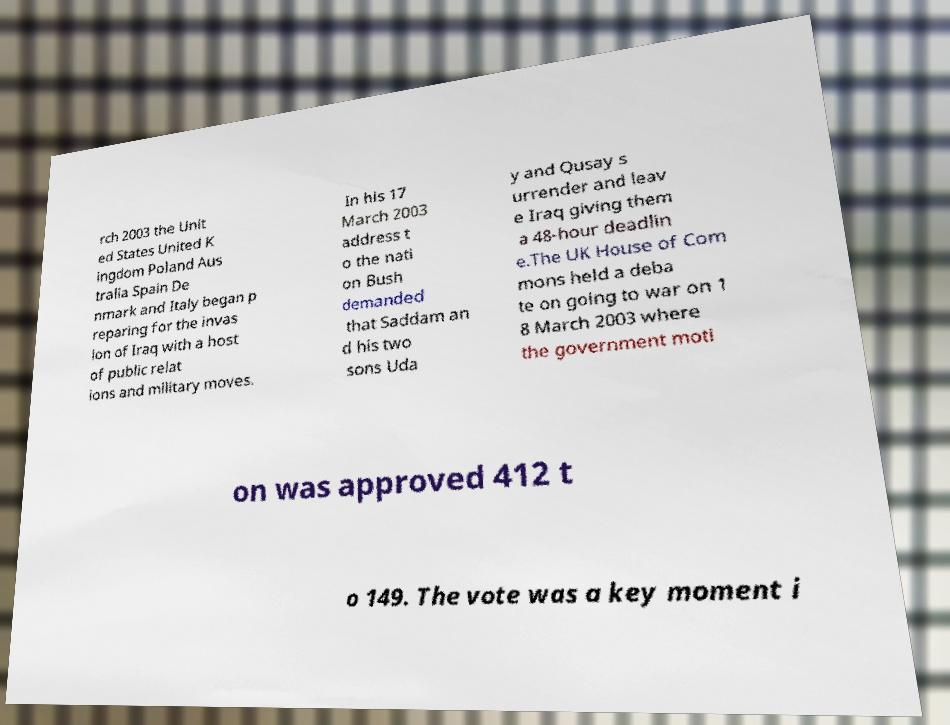Can you read and provide the text displayed in the image?This photo seems to have some interesting text. Can you extract and type it out for me? rch 2003 the Unit ed States United K ingdom Poland Aus tralia Spain De nmark and Italy began p reparing for the invas ion of Iraq with a host of public relat ions and military moves. In his 17 March 2003 address t o the nati on Bush demanded that Saddam an d his two sons Uda y and Qusay s urrender and leav e Iraq giving them a 48-hour deadlin e.The UK House of Com mons held a deba te on going to war on 1 8 March 2003 where the government moti on was approved 412 t o 149. The vote was a key moment i 